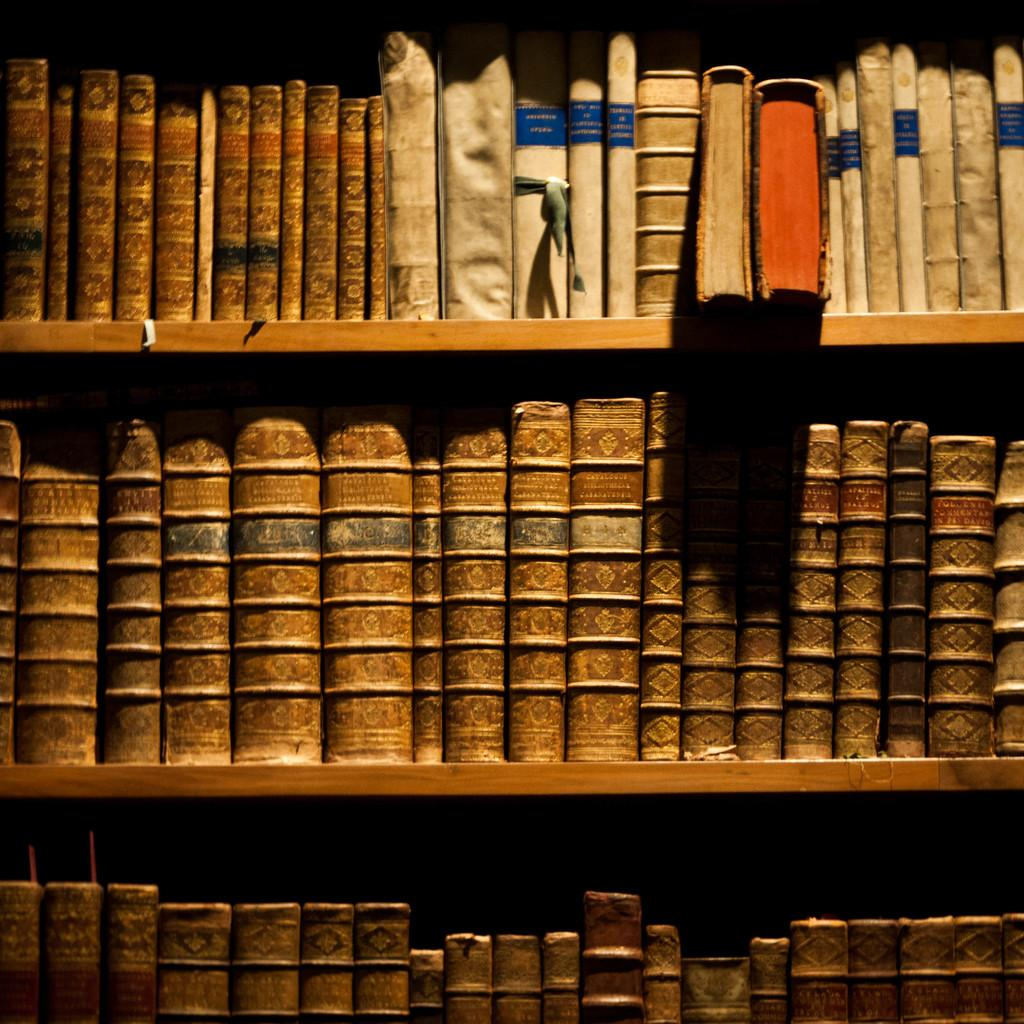What objects can be seen in the image? There are books in the image. How are the books organized or stored in the image? The books are in racks. Can you see any honey dripping from the books in the image? There is no honey present in the image, and the books are not depicted as dripping anything. 